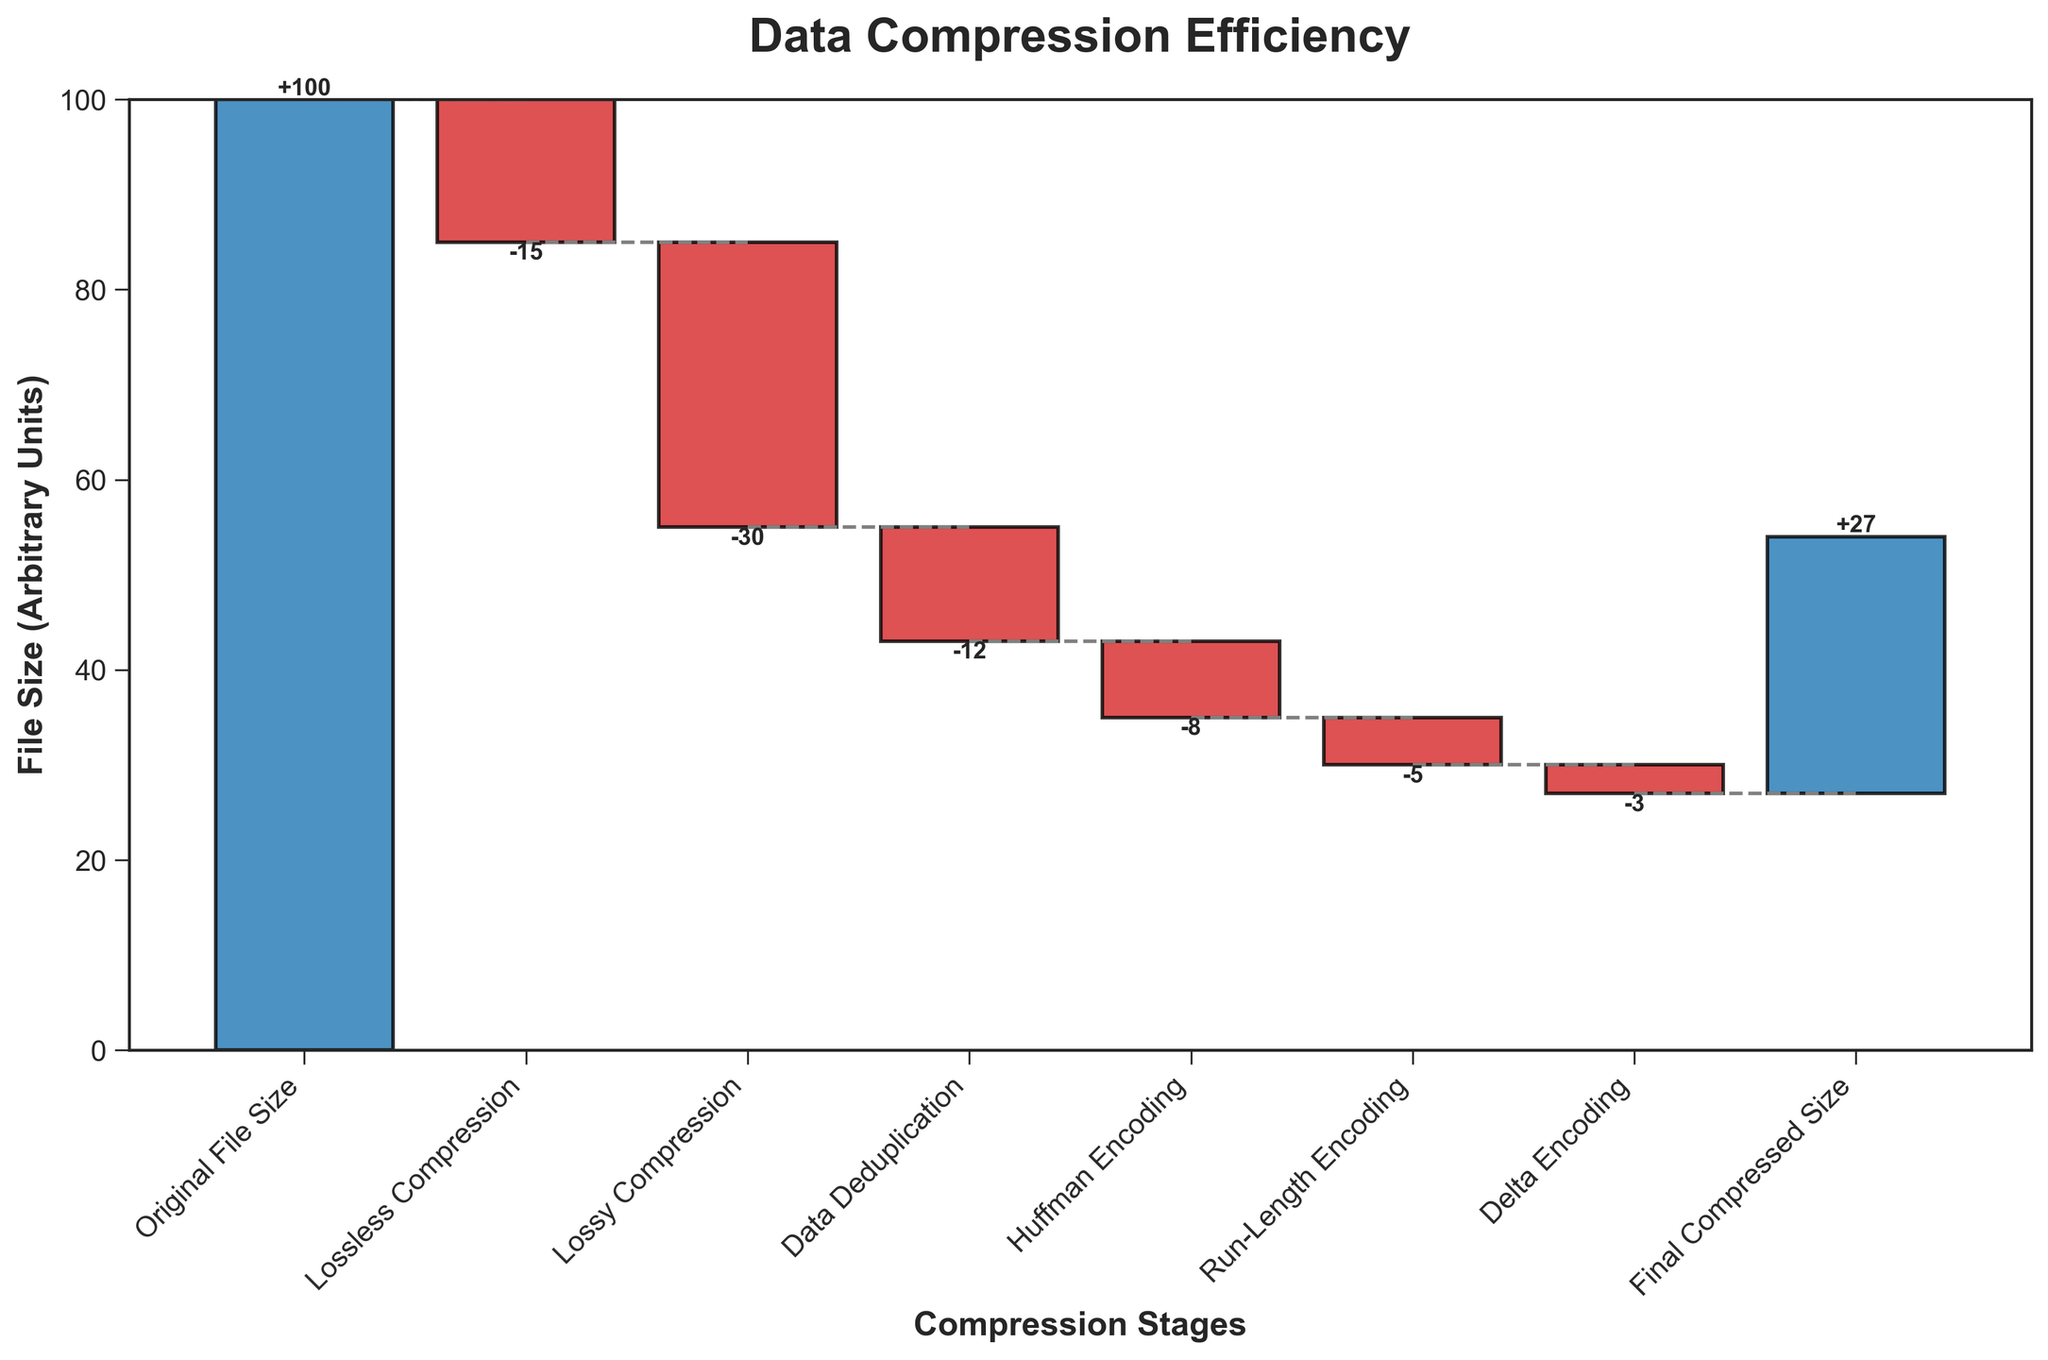What is the title of the chart? The title of the chart is located at the top and prominently displayed. It provides a summary of what the chart is about.
Answer: Data Compression Efficiency What is the final compressed file size? The final compressed file size is given as the last stage in the chart labeled "Final Compressed Size." From the chart, we can read the corresponding value.
Answer: 27 What stage has the largest reduction in file size? To determine the stage with the largest reduction, look for the stage with the most significant negative value. The stages are labeled along the x-axis with their respective values visually represented.
Answer: Lossy Compression How much total file size reduction is achieved by all the compression methods combined? Calculate the total file size reduction by summing all the negative values shown in the figure. Add up the values for Lossless Compression, Lossy Compression, Data Deduplication, Huffman Encoding, Run-Length Encoding, and Delta Encoding.
Answer: -73 Which stages contribute to reducing the file size by more than 10 units? To find the stages that contribute to reducing the file size by more than 10 units, identify the stages with negative values greater than 10. Check each stage on the x-axis and their corresponding values.
Answer: Lossless Compression, Lossy Compression, Data Deduplication What are the cumulative file sizes after each stage of compression? The cumulative file sizes are derived by adding the values sequentially. Start with the original file size and add the value of each subsequent stage to the previous cumulative total.
Answer: 100 -> 85 -> 55 -> 43 -> 35 -> 30 -> 27 How does the reduction from Lossless Compression compare to Huffman Encoding? Compare the absolute values of the reductions caused by Lossless Compression and Huffman Encoding. Look at the stage values for both and see which is greater.
Answer: Lossless Compression has a larger reduction than Huffman Encoding What is the difference in file size reduction between Lossy Compression and Data Deduplication? Subtract the reduction caused by Data Deduplication from the reduction caused by Lossy Compression. Both are negative values, so consider their magnitudes.
Answer: 18 Do any stages increase the file size? Scan through the stages and their values to see if any of them are positive. In this case, all reductions are negative values which implies there are no increases.
Answer: No What is the cumulative reduction in file size right before the final stage (Final Compressed Size)? Calculate the cumulative reduction by summing all file reductions except the final stage. Add up the values of all previous stages and subtract from the original file size.
Answer: 73 